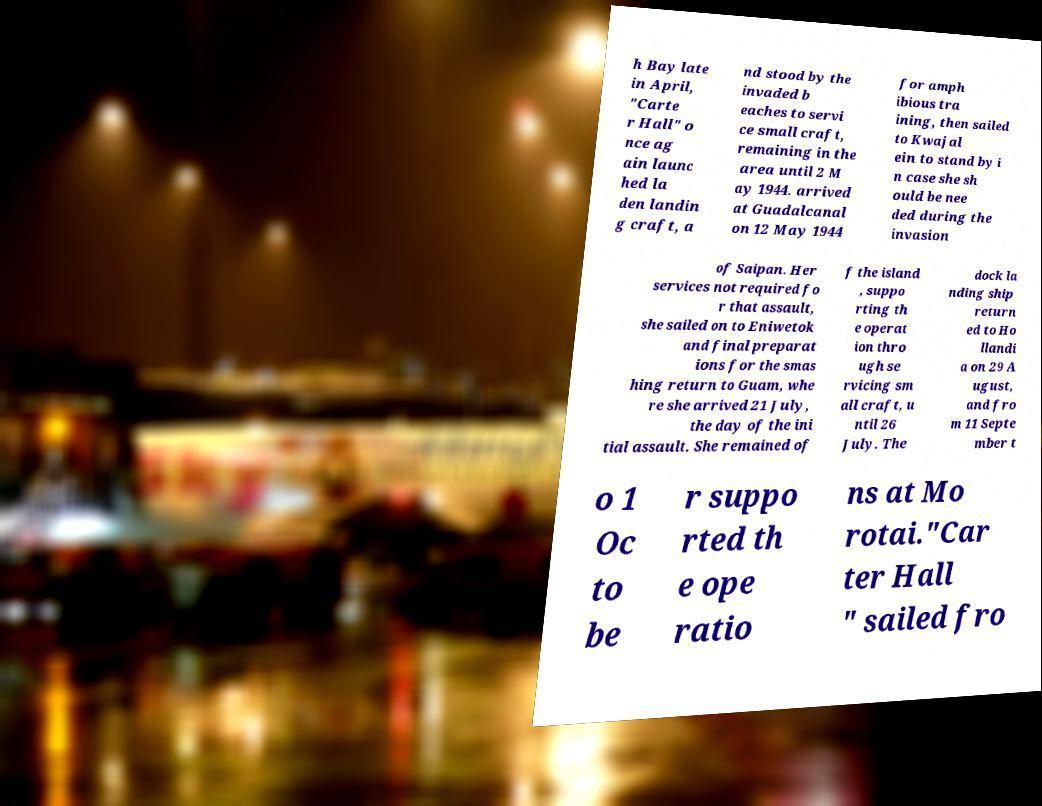Please read and relay the text visible in this image. What does it say? h Bay late in April, "Carte r Hall" o nce ag ain launc hed la den landin g craft, a nd stood by the invaded b eaches to servi ce small craft, remaining in the area until 2 M ay 1944. arrived at Guadalcanal on 12 May 1944 for amph ibious tra ining, then sailed to Kwajal ein to stand by i n case she sh ould be nee ded during the invasion of Saipan. Her services not required fo r that assault, she sailed on to Eniwetok and final preparat ions for the smas hing return to Guam, whe re she arrived 21 July, the day of the ini tial assault. She remained of f the island , suppo rting th e operat ion thro ugh se rvicing sm all craft, u ntil 26 July. The dock la nding ship return ed to Ho llandi a on 29 A ugust, and fro m 11 Septe mber t o 1 Oc to be r suppo rted th e ope ratio ns at Mo rotai."Car ter Hall " sailed fro 